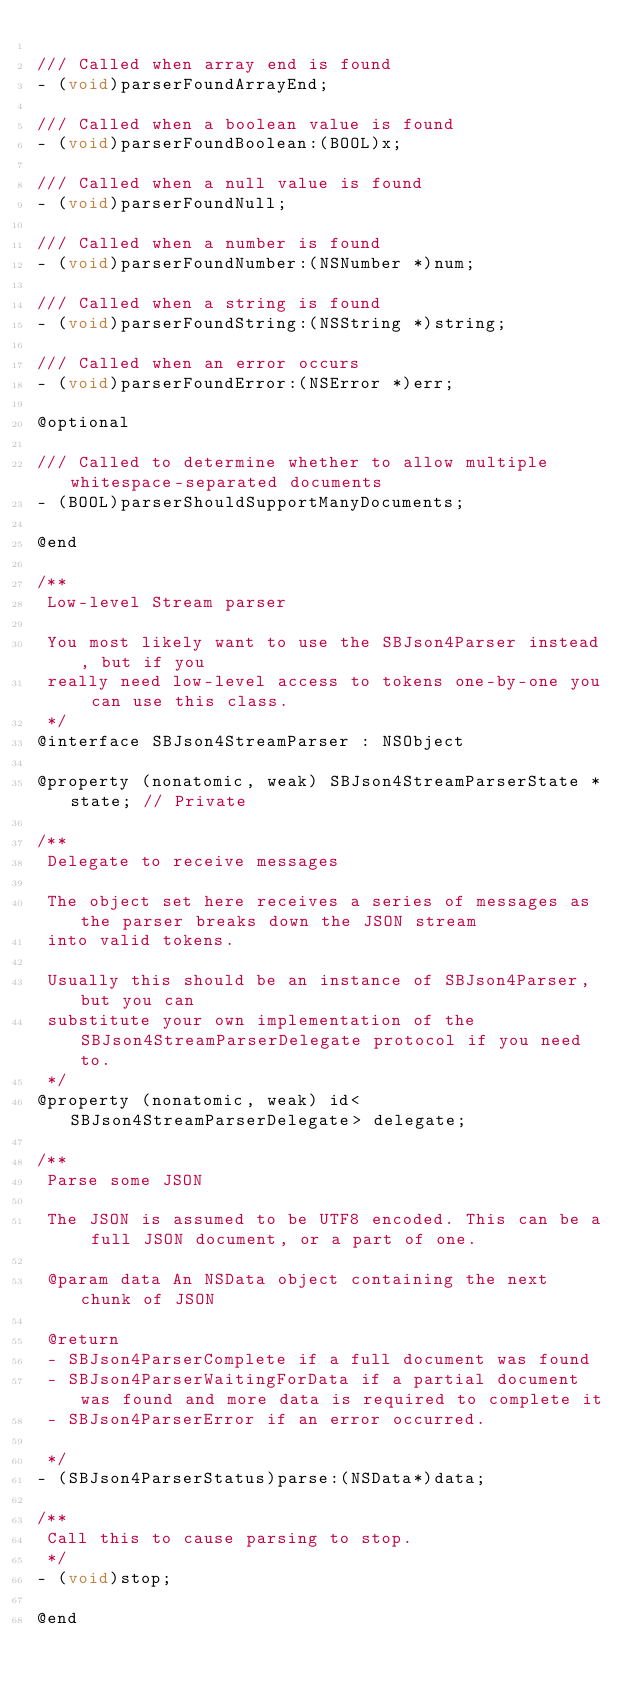<code> <loc_0><loc_0><loc_500><loc_500><_C_>
/// Called when array end is found
- (void)parserFoundArrayEnd;

/// Called when a boolean value is found
- (void)parserFoundBoolean:(BOOL)x;

/// Called when a null value is found
- (void)parserFoundNull;

/// Called when a number is found
- (void)parserFoundNumber:(NSNumber *)num;

/// Called when a string is found
- (void)parserFoundString:(NSString *)string;

/// Called when an error occurs
- (void)parserFoundError:(NSError *)err;

@optional

/// Called to determine whether to allow multiple whitespace-separated documents
- (BOOL)parserShouldSupportManyDocuments;

@end

/**
 Low-level Stream parser

 You most likely want to use the SBJson4Parser instead, but if you
 really need low-level access to tokens one-by-one you can use this class.
 */
@interface SBJson4StreamParser : NSObject

@property (nonatomic, weak) SBJson4StreamParserState *state; // Private

/**
 Delegate to receive messages

 The object set here receives a series of messages as the parser breaks down the JSON stream
 into valid tokens.

 Usually this should be an instance of SBJson4Parser, but you can
 substitute your own implementation of the SBJson4StreamParserDelegate protocol if you need to.
 */
@property (nonatomic, weak) id<SBJson4StreamParserDelegate> delegate;

/**
 Parse some JSON

 The JSON is assumed to be UTF8 encoded. This can be a full JSON document, or a part of one.

 @param data An NSData object containing the next chunk of JSON

 @return
 - SBJson4ParserComplete if a full document was found
 - SBJson4ParserWaitingForData if a partial document was found and more data is required to complete it
 - SBJson4ParserError if an error occurred.

 */
- (SBJson4ParserStatus)parse:(NSData*)data;

/**
 Call this to cause parsing to stop.
 */
- (void)stop;

@end
</code> 